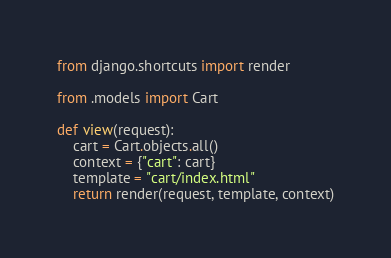Convert code to text. <code><loc_0><loc_0><loc_500><loc_500><_Python_>
from django.shortcuts import render

from .models import Cart

def view(request):
    cart = Cart.objects.all()
    context = {"cart": cart}
    template = "cart/index.html"
    return render(request, template, context)



</code> 